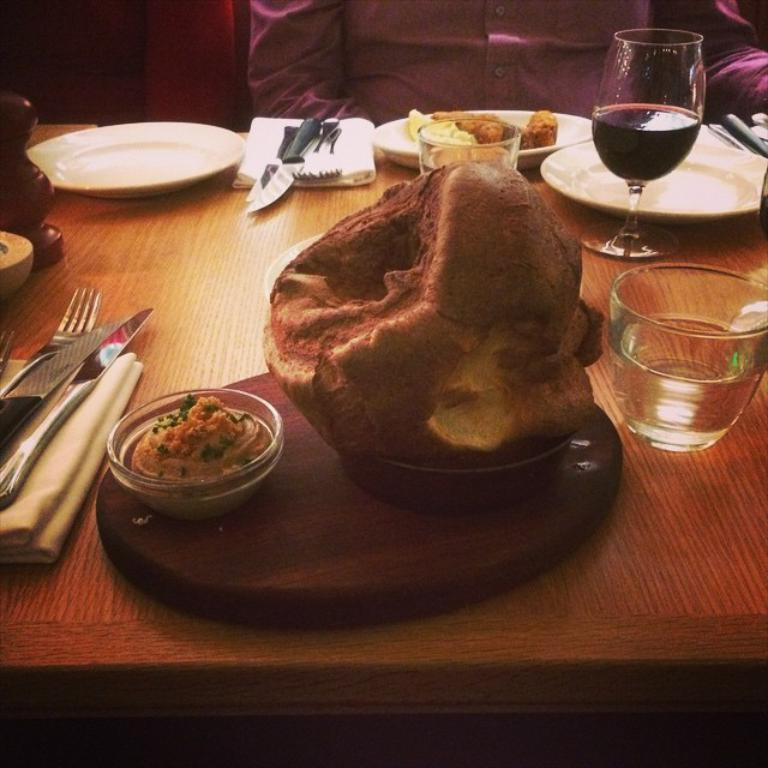What type of tableware can be seen in the image? Plates, knives, forks, and glasses can be seen in the image. What items might be used for cleaning or wiping in the image? Napkins are present in the image for cleaning or wiping. What type of food items are visible in the image? There are food items in the image. What other objects can be seen on the table in the image? There are other objects on the table in the image. Can you describe the person in the background of the image? There is a person sitting in the background of the image. What type of underwear is the person in the image wearing? There is no information about the person's underwear in the image, as it is not visible or mentioned in the provided facts. 